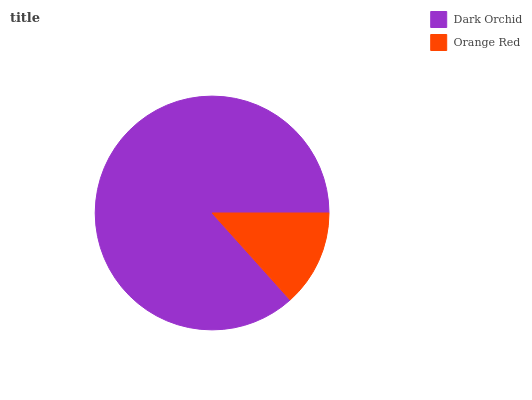Is Orange Red the minimum?
Answer yes or no. Yes. Is Dark Orchid the maximum?
Answer yes or no. Yes. Is Orange Red the maximum?
Answer yes or no. No. Is Dark Orchid greater than Orange Red?
Answer yes or no. Yes. Is Orange Red less than Dark Orchid?
Answer yes or no. Yes. Is Orange Red greater than Dark Orchid?
Answer yes or no. No. Is Dark Orchid less than Orange Red?
Answer yes or no. No. Is Dark Orchid the high median?
Answer yes or no. Yes. Is Orange Red the low median?
Answer yes or no. Yes. Is Orange Red the high median?
Answer yes or no. No. Is Dark Orchid the low median?
Answer yes or no. No. 